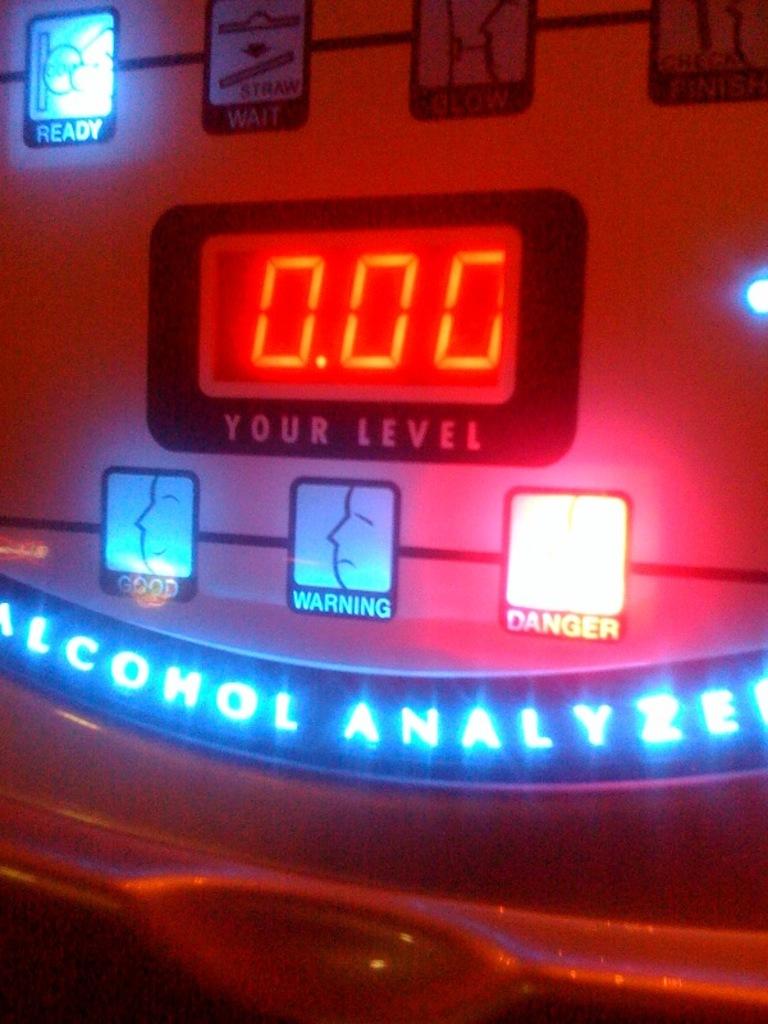What does the sing on the bottom left say?
Keep it short and to the point. Good. 